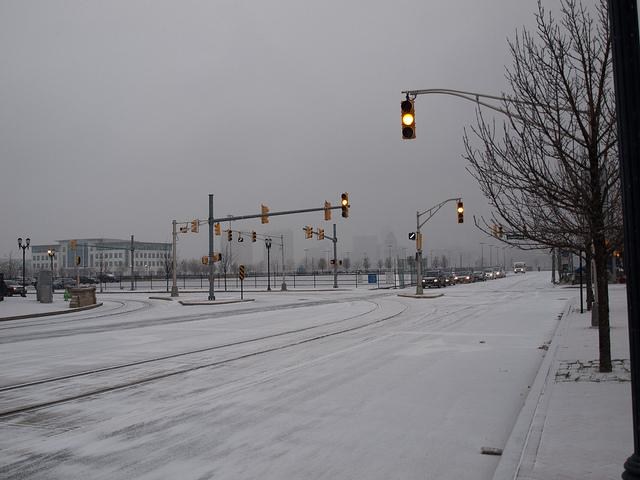Why has caused traffic to be so light on this roadway? snow 